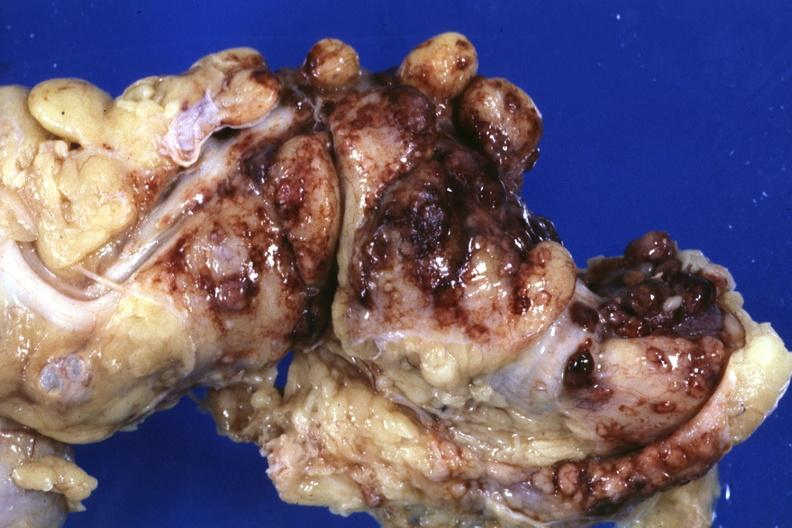s abdomen present?
Answer the question using a single word or phrase. Yes 